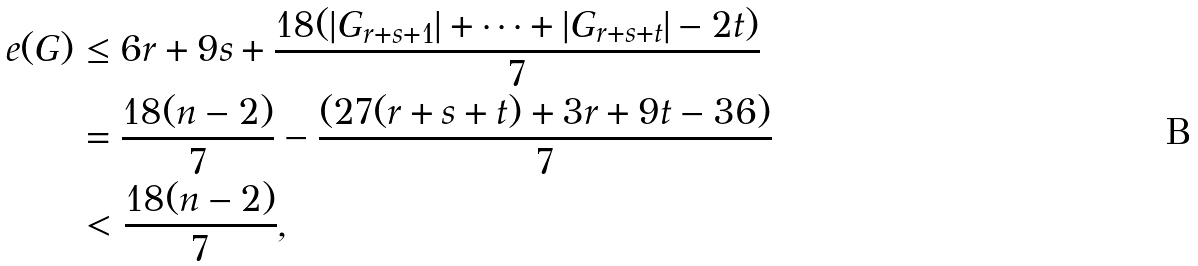Convert formula to latex. <formula><loc_0><loc_0><loc_500><loc_500>e ( G ) & \leq 6 r + 9 s + \frac { 1 8 ( | G _ { r + s + 1 } | + \cdots + | G _ { r + s + t } | - 2 t ) } 7 \\ & = \frac { 1 8 ( n - 2 ) } 7 - \frac { ( 2 7 ( r + s + t ) + 3 r + 9 t - 3 6 ) } 7 \\ & < \frac { 1 8 ( n - 2 ) } 7 ,</formula> 